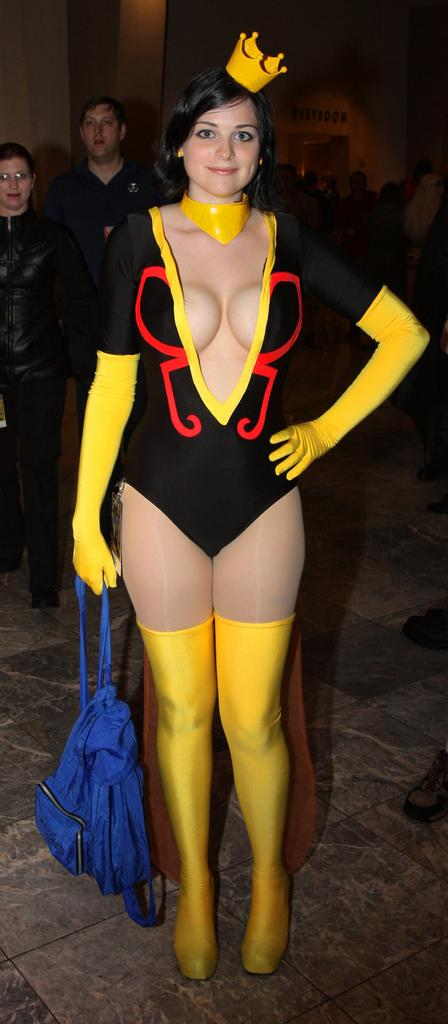What is the main subject in the foreground of the picture? There is a woman standing in the foreground of the picture. Where are the other two persons located in the image? The two persons are on the left side of the image. Can you describe the background of the image? There are people and a wall in the background of the image. What type of fish can be seen singing a song in the image? There is no fish or singing in the image; it features a woman in the foreground and two persons on the left side, with people and a wall in the background. 